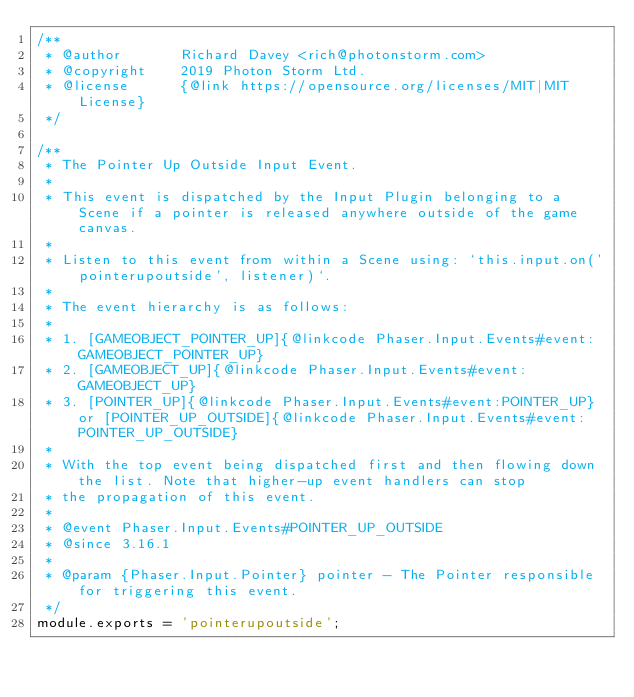<code> <loc_0><loc_0><loc_500><loc_500><_JavaScript_>/**
 * @author       Richard Davey <rich@photonstorm.com>
 * @copyright    2019 Photon Storm Ltd.
 * @license      {@link https://opensource.org/licenses/MIT|MIT License}
 */

/**
 * The Pointer Up Outside Input Event.
 * 
 * This event is dispatched by the Input Plugin belonging to a Scene if a pointer is released anywhere outside of the game canvas.
 * 
 * Listen to this event from within a Scene using: `this.input.on('pointerupoutside', listener)`.
 * 
 * The event hierarchy is as follows:
 * 
 * 1. [GAMEOBJECT_POINTER_UP]{@linkcode Phaser.Input.Events#event:GAMEOBJECT_POINTER_UP}
 * 2. [GAMEOBJECT_UP]{@linkcode Phaser.Input.Events#event:GAMEOBJECT_UP}
 * 3. [POINTER_UP]{@linkcode Phaser.Input.Events#event:POINTER_UP} or [POINTER_UP_OUTSIDE]{@linkcode Phaser.Input.Events#event:POINTER_UP_OUTSIDE}
 * 
 * With the top event being dispatched first and then flowing down the list. Note that higher-up event handlers can stop
 * the propagation of this event.
 *
 * @event Phaser.Input.Events#POINTER_UP_OUTSIDE
 * @since 3.16.1
 * 
 * @param {Phaser.Input.Pointer} pointer - The Pointer responsible for triggering this event.
 */
module.exports = 'pointerupoutside';
</code> 